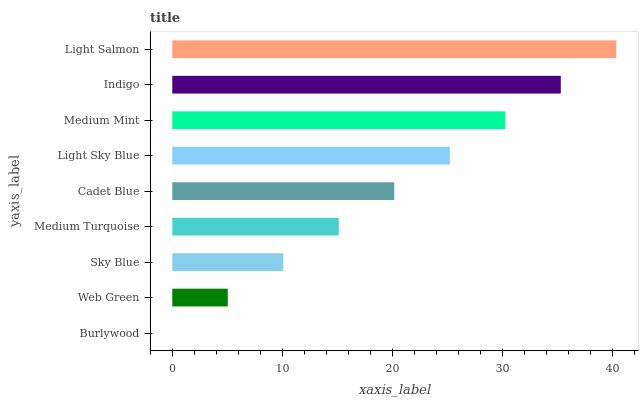Is Burlywood the minimum?
Answer yes or no. Yes. Is Light Salmon the maximum?
Answer yes or no. Yes. Is Web Green the minimum?
Answer yes or no. No. Is Web Green the maximum?
Answer yes or no. No. Is Web Green greater than Burlywood?
Answer yes or no. Yes. Is Burlywood less than Web Green?
Answer yes or no. Yes. Is Burlywood greater than Web Green?
Answer yes or no. No. Is Web Green less than Burlywood?
Answer yes or no. No. Is Cadet Blue the high median?
Answer yes or no. Yes. Is Cadet Blue the low median?
Answer yes or no. Yes. Is Web Green the high median?
Answer yes or no. No. Is Burlywood the low median?
Answer yes or no. No. 